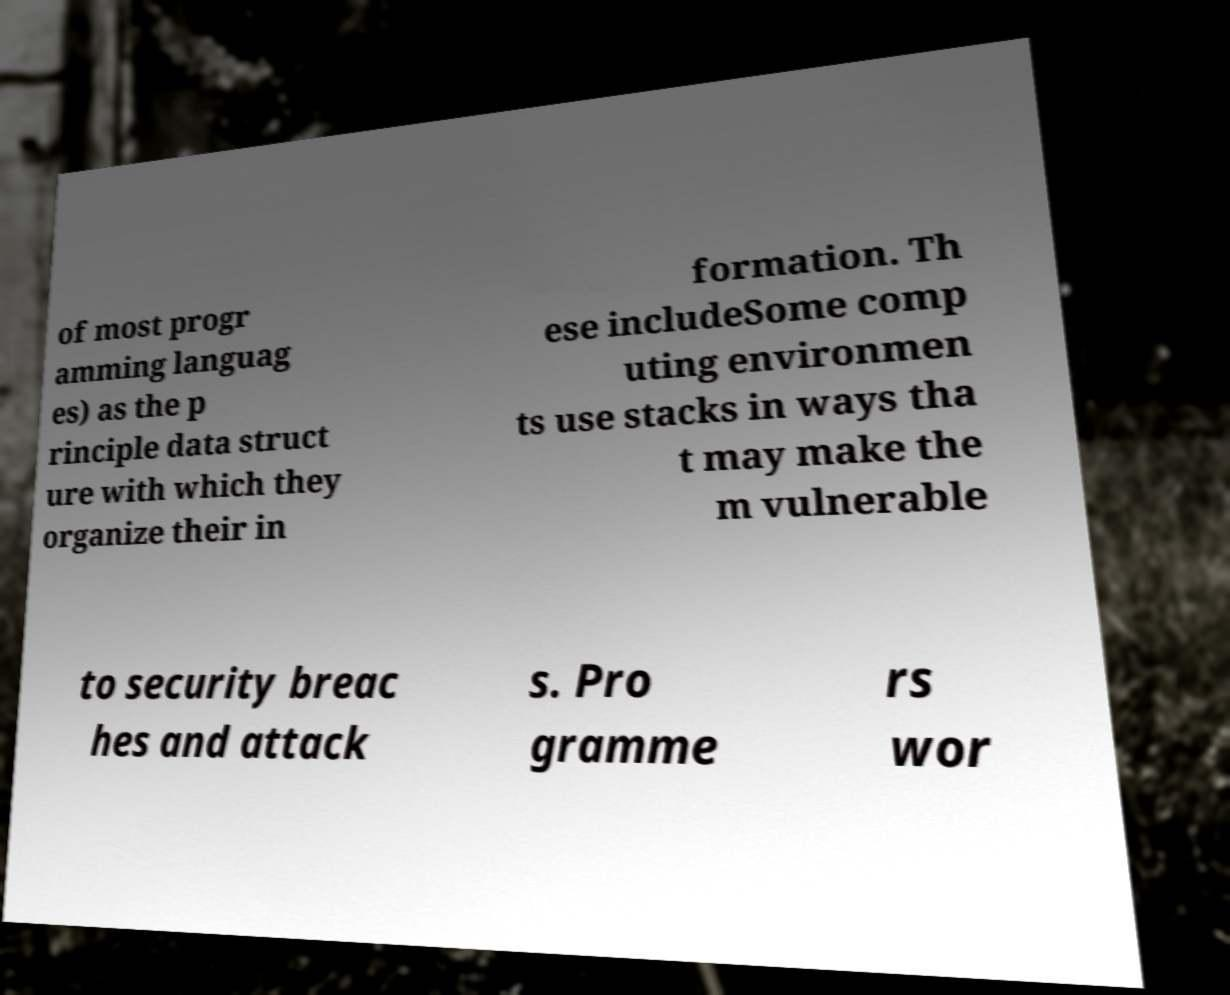Can you accurately transcribe the text from the provided image for me? of most progr amming languag es) as the p rinciple data struct ure with which they organize their in formation. Th ese includeSome comp uting environmen ts use stacks in ways tha t may make the m vulnerable to security breac hes and attack s. Pro gramme rs wor 